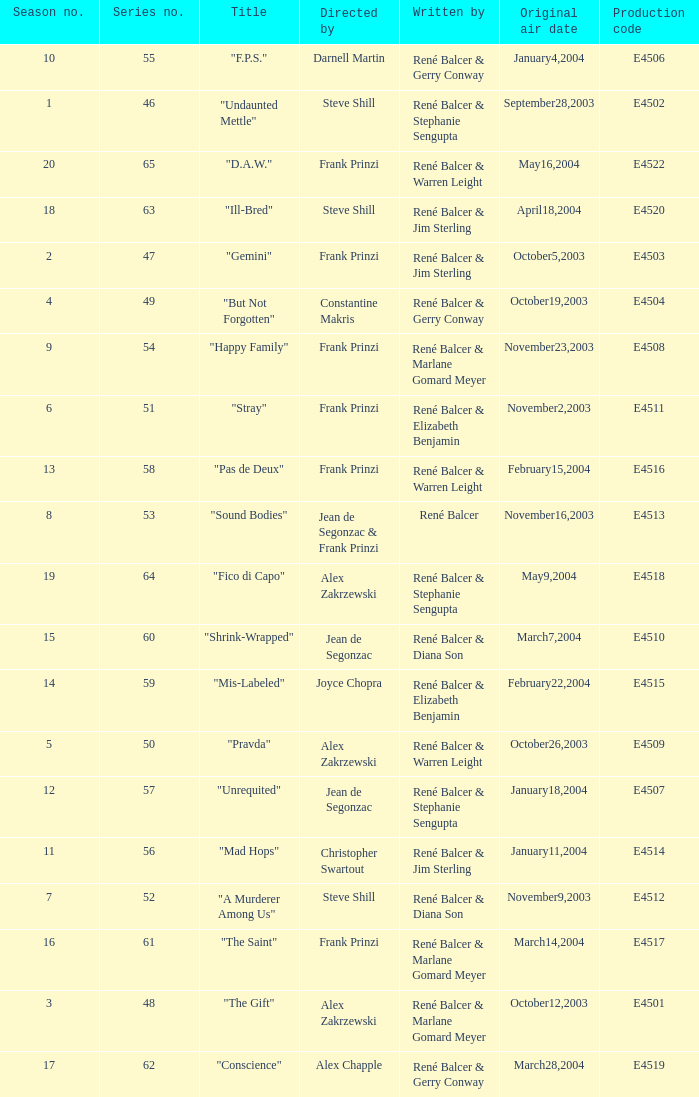What date did "d.a.w." Originally air? May16,2004. 